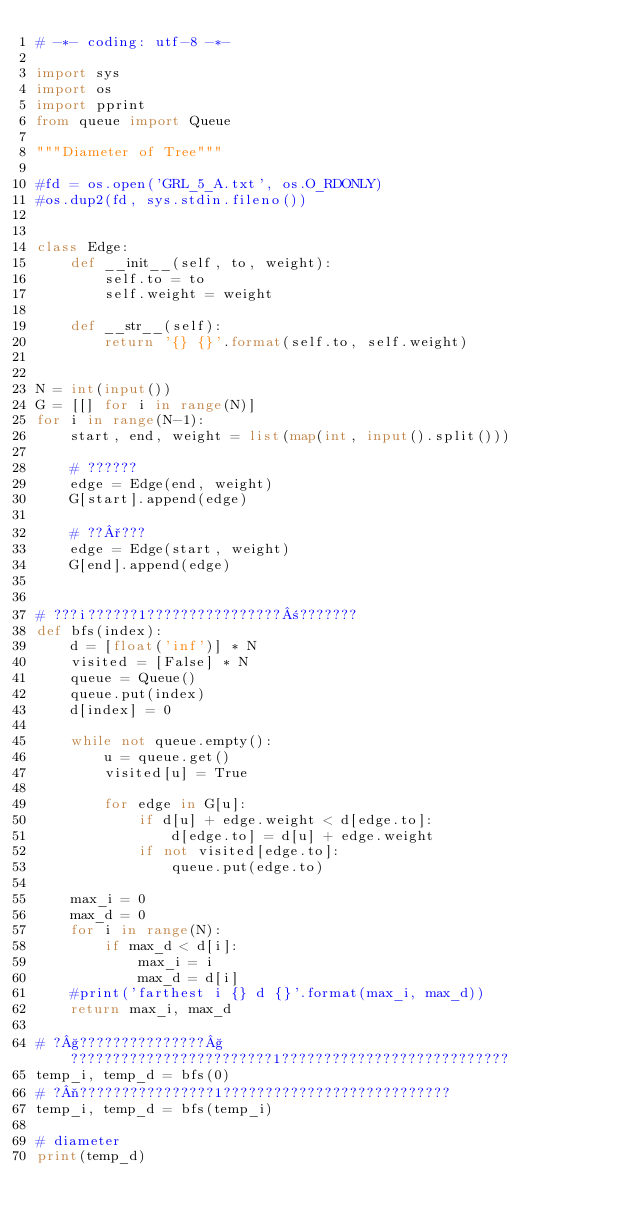<code> <loc_0><loc_0><loc_500><loc_500><_Python_># -*- coding: utf-8 -*-

import sys
import os
import pprint
from queue import Queue

"""Diameter of Tree"""

#fd = os.open('GRL_5_A.txt', os.O_RDONLY)
#os.dup2(fd, sys.stdin.fileno())


class Edge:
    def __init__(self, to, weight):
        self.to = to
        self.weight = weight

    def __str__(self):
        return '{} {}'.format(self.to, self.weight)


N = int(input())
G = [[] for i in range(N)]
for i in range(N-1):
    start, end, weight = list(map(int, input().split()))

    # ??????
    edge = Edge(end, weight)
    G[start].append(edge)

    # ??°???
    edge = Edge(start, weight)
    G[end].append(edge)


# ???i??????1????????????????±???????
def bfs(index):
    d = [float('inf')] * N
    visited = [False] * N
    queue = Queue()
    queue.put(index)
    d[index] = 0

    while not queue.empty():
        u = queue.get()
        visited[u] = True

        for edge in G[u]:
            if d[u] + edge.weight < d[edge.to]:
                d[edge.to] = d[u] + edge.weight
            if not visited[edge.to]:
                queue.put(edge.to)

    max_i = 0
    max_d = 0
    for i in range(N):
        if max_d < d[i]:
            max_i = i
            max_d = d[i]
    #print('farthest i {} d {}'.format(max_i, max_d))
    return max_i, max_d

# ?§???????????????§????????????????????????1???????????????????????????
temp_i, temp_d = bfs(0)
# ?¬????????????????1???????????????????????????
temp_i, temp_d = bfs(temp_i)

# diameter
print(temp_d)</code> 